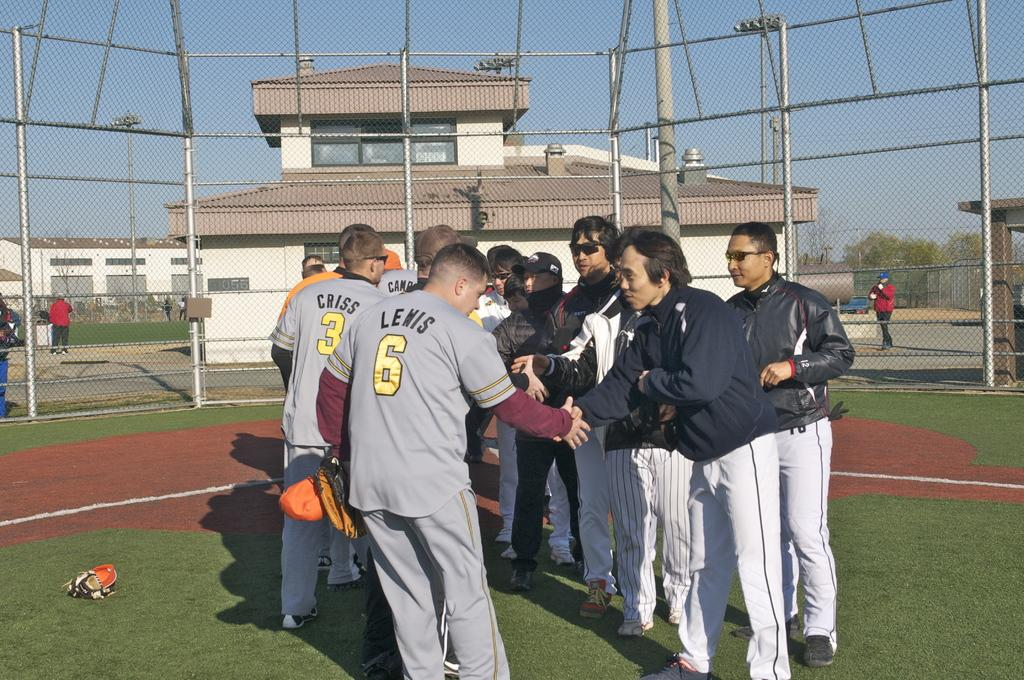<image>
Provide a brief description of the given image. Sports players with the numbers 6 and 3 shake hands with a group of other people. 